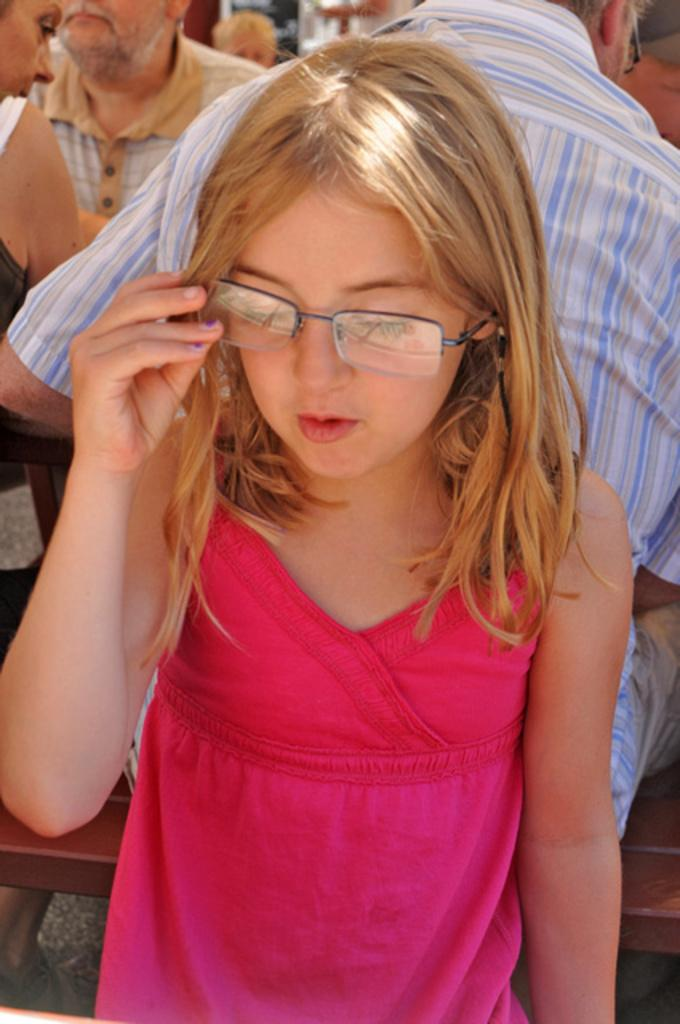Where was the image taken? The image was taken indoors. Who is the main subject in the image? A girl is standing in the middle of the image. What is the girl wearing? The girl is wearing spectacles. What can be seen in the background of the image? There are people sitting on benches in the background. How much money is the girl holding in the image? There is no indication of money in the image; the girl is not holding any. Is there a tent visible in the image? No, there is no tent present in the image. 